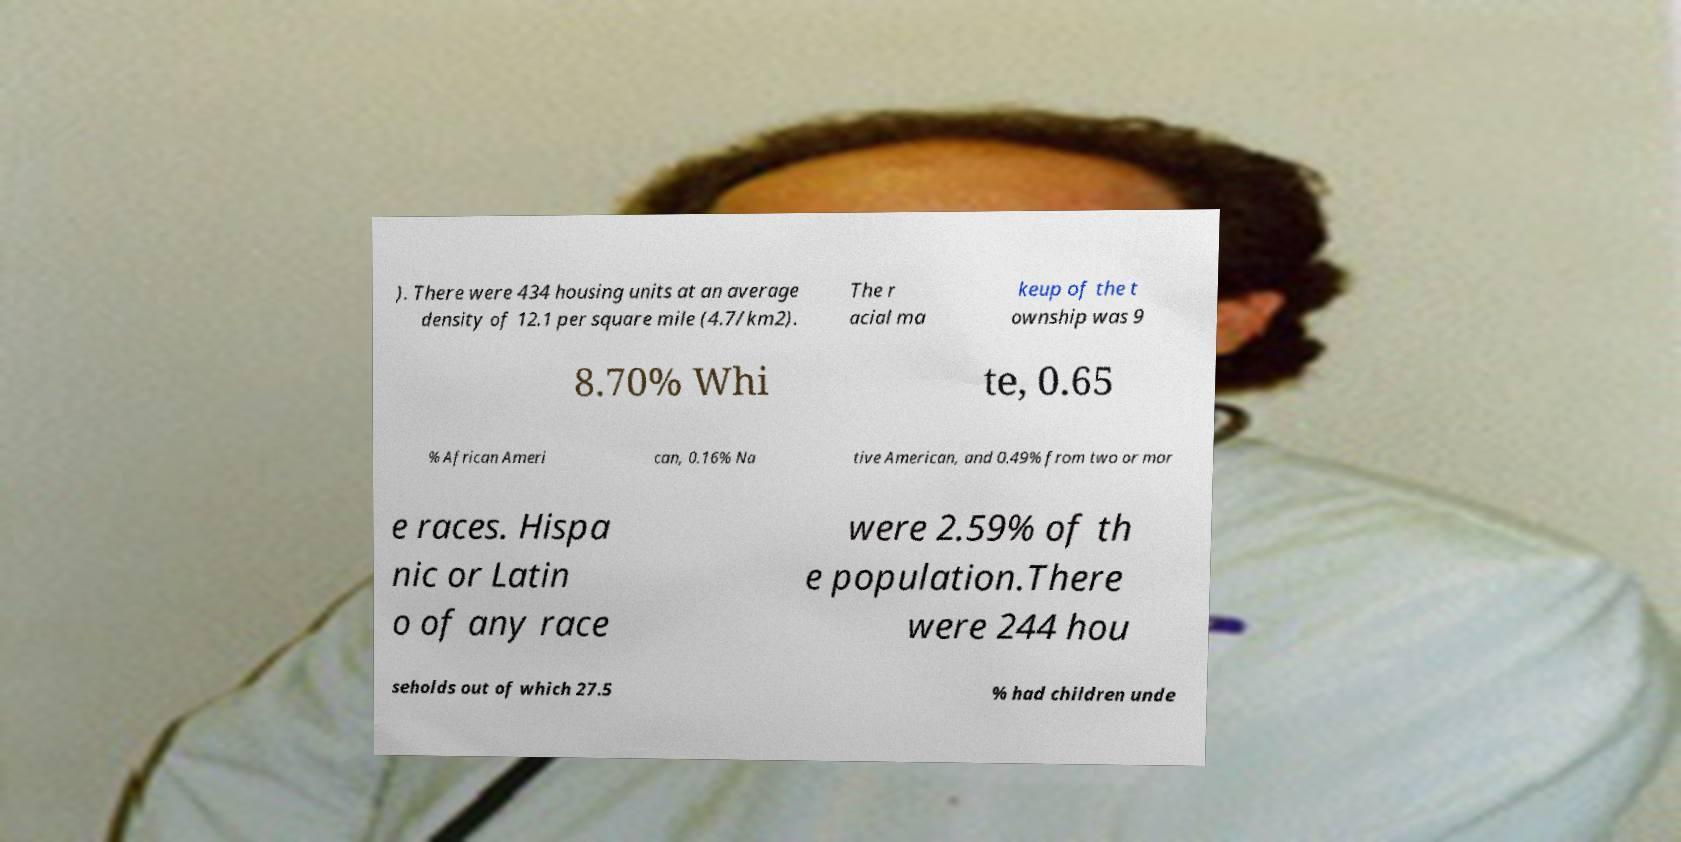I need the written content from this picture converted into text. Can you do that? ). There were 434 housing units at an average density of 12.1 per square mile (4.7/km2). The r acial ma keup of the t ownship was 9 8.70% Whi te, 0.65 % African Ameri can, 0.16% Na tive American, and 0.49% from two or mor e races. Hispa nic or Latin o of any race were 2.59% of th e population.There were 244 hou seholds out of which 27.5 % had children unde 